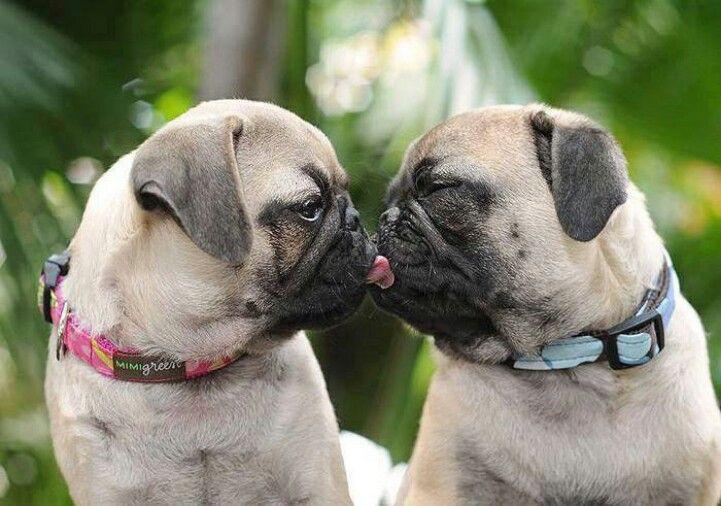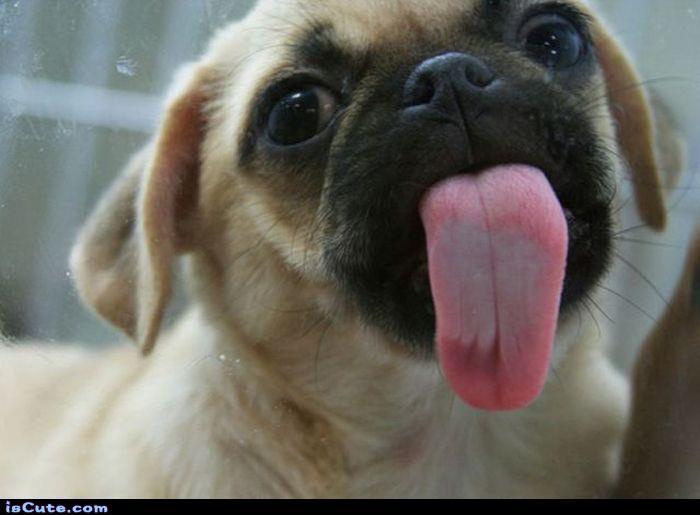The first image is the image on the left, the second image is the image on the right. Assess this claim about the two images: "The left and right image contains the same number of dogs.". Correct or not? Answer yes or no. No. 